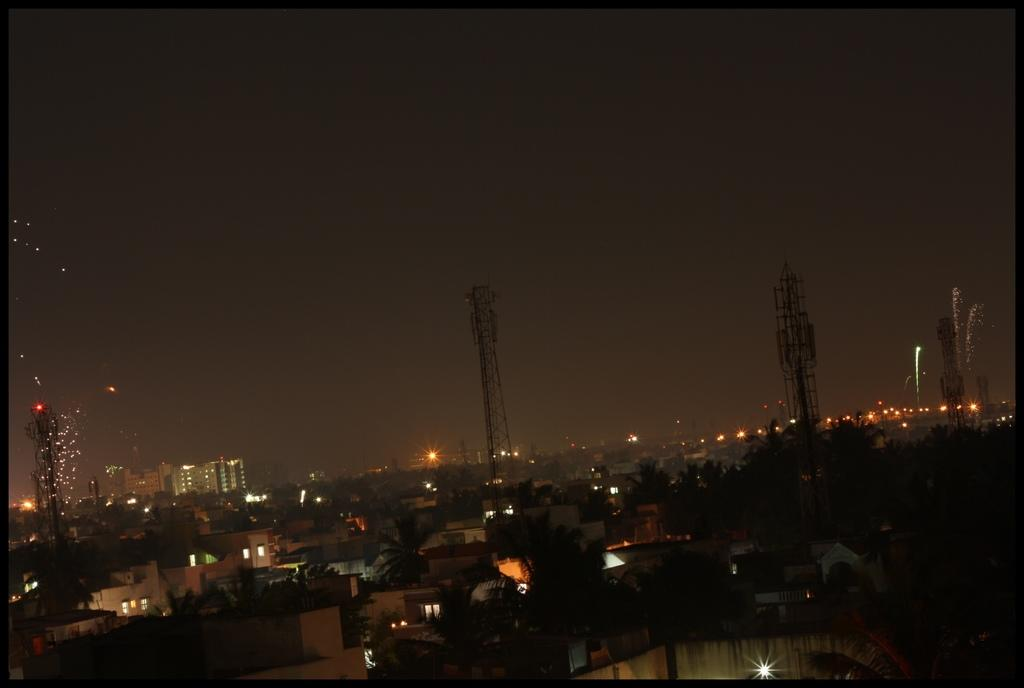What type of natural elements can be seen in the image? There are trees in the image. What type of man-made structures are present in the image? There are buildings and towers in the image. What type of illumination is visible in the image? There are lights in the image. What type of doctor can be seen treating patients in the image? There is no doctor present in the image; it features trees, buildings, towers, and lights. What type of plantation is visible in the image? There is no plantation present in the image; it features trees, buildings, towers, and lights. 